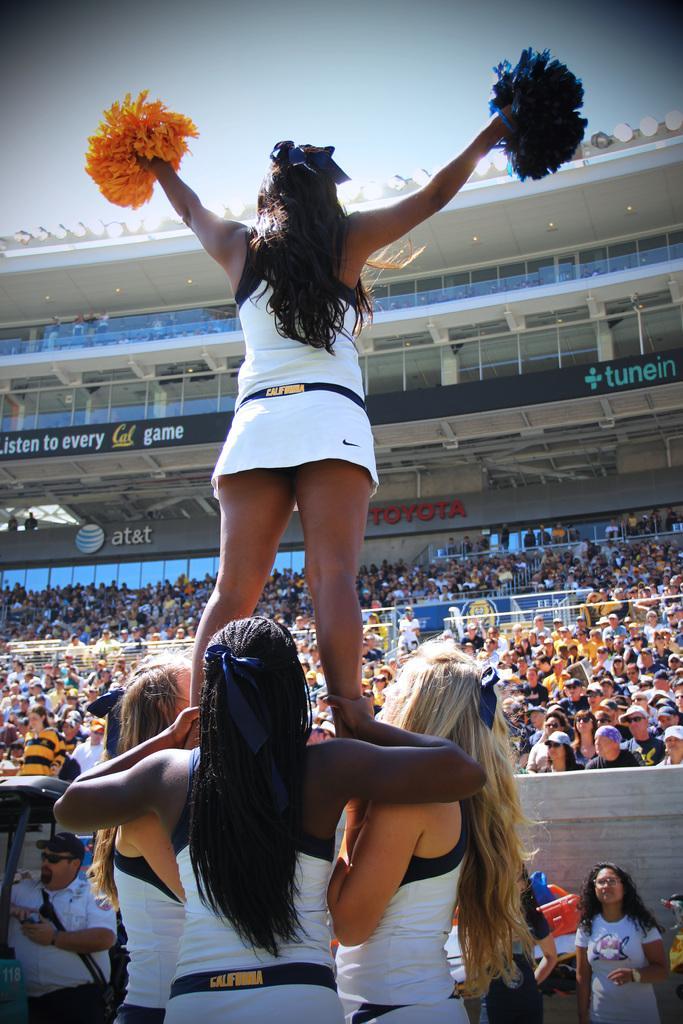How would you summarize this image in a sentence or two? In this picture we can see group of people, in the middle of the image we can see a woman, she is holding poms, in the background we can see hoardings and lights. 